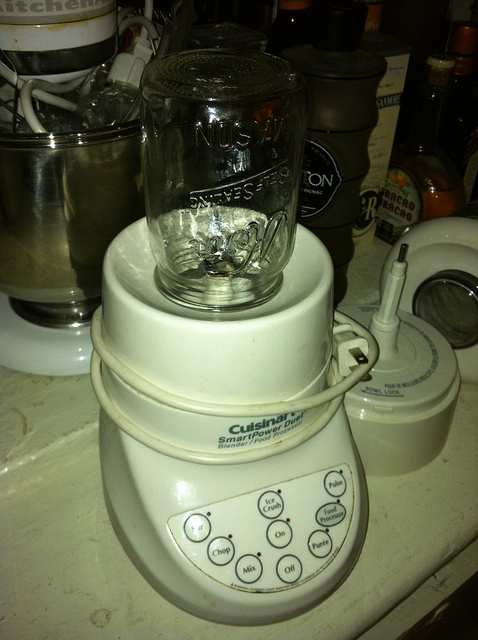Extract all visible text content from this image. Cuisinar TON 